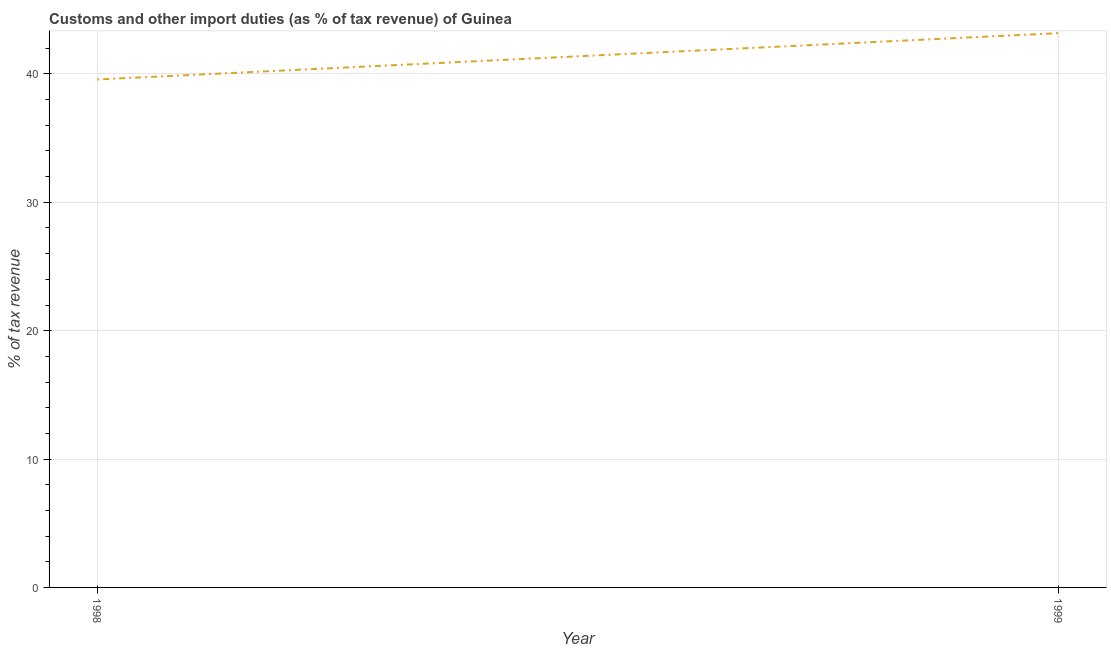What is the customs and other import duties in 1999?
Offer a terse response. 43.18. Across all years, what is the maximum customs and other import duties?
Offer a terse response. 43.18. Across all years, what is the minimum customs and other import duties?
Your response must be concise. 39.57. In which year was the customs and other import duties maximum?
Your answer should be very brief. 1999. In which year was the customs and other import duties minimum?
Provide a succinct answer. 1998. What is the sum of the customs and other import duties?
Provide a short and direct response. 82.74. What is the difference between the customs and other import duties in 1998 and 1999?
Give a very brief answer. -3.61. What is the average customs and other import duties per year?
Keep it short and to the point. 41.37. What is the median customs and other import duties?
Give a very brief answer. 41.37. What is the ratio of the customs and other import duties in 1998 to that in 1999?
Your answer should be compact. 0.92. In how many years, is the customs and other import duties greater than the average customs and other import duties taken over all years?
Provide a succinct answer. 1. What is the difference between two consecutive major ticks on the Y-axis?
Ensure brevity in your answer.  10. What is the title of the graph?
Your answer should be very brief. Customs and other import duties (as % of tax revenue) of Guinea. What is the label or title of the Y-axis?
Provide a short and direct response. % of tax revenue. What is the % of tax revenue of 1998?
Ensure brevity in your answer.  39.57. What is the % of tax revenue of 1999?
Give a very brief answer. 43.18. What is the difference between the % of tax revenue in 1998 and 1999?
Your answer should be very brief. -3.61. What is the ratio of the % of tax revenue in 1998 to that in 1999?
Provide a short and direct response. 0.92. 